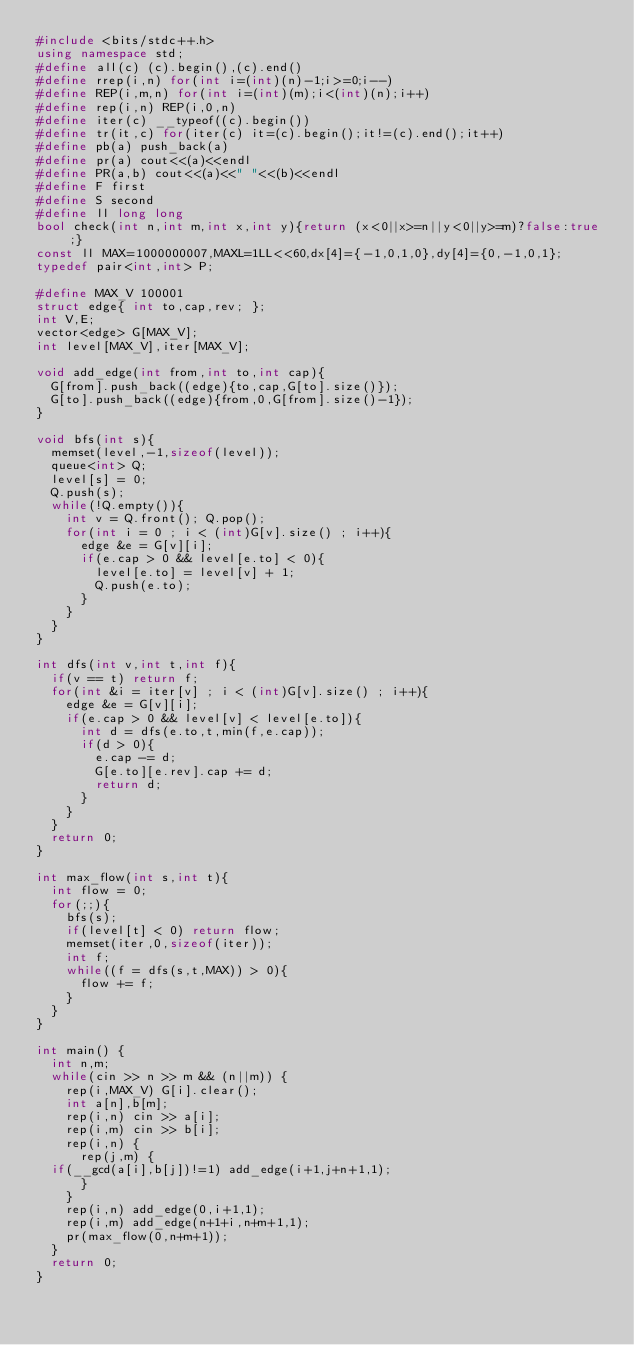<code> <loc_0><loc_0><loc_500><loc_500><_C++_>#include <bits/stdc++.h>
using namespace std;
#define all(c) (c).begin(),(c).end()
#define rrep(i,n) for(int i=(int)(n)-1;i>=0;i--)
#define REP(i,m,n) for(int i=(int)(m);i<(int)(n);i++)
#define rep(i,n) REP(i,0,n)
#define iter(c) __typeof((c).begin())
#define tr(it,c) for(iter(c) it=(c).begin();it!=(c).end();it++)
#define pb(a) push_back(a)
#define pr(a) cout<<(a)<<endl
#define PR(a,b) cout<<(a)<<" "<<(b)<<endl
#define F first
#define S second
#define ll long long
bool check(int n,int m,int x,int y){return (x<0||x>=n||y<0||y>=m)?false:true;}
const ll MAX=1000000007,MAXL=1LL<<60,dx[4]={-1,0,1,0},dy[4]={0,-1,0,1};
typedef pair<int,int> P;

#define MAX_V 100001
struct edge{ int to,cap,rev; };  
int V,E;
vector<edge> G[MAX_V];
int level[MAX_V],iter[MAX_V];
  
void add_edge(int from,int to,int cap){
  G[from].push_back((edge){to,cap,G[to].size()});
  G[to].push_back((edge){from,0,G[from].size()-1});
}
  
void bfs(int s){
  memset(level,-1,sizeof(level));
  queue<int> Q;
  level[s] = 0;
  Q.push(s);
  while(!Q.empty()){
    int v = Q.front(); Q.pop();
    for(int i = 0 ; i < (int)G[v].size() ; i++){
      edge &e = G[v][i];
      if(e.cap > 0 && level[e.to] < 0){
        level[e.to] = level[v] + 1;
        Q.push(e.to);
      }
    }
  }
}
  
int dfs(int v,int t,int f){
  if(v == t) return f;
  for(int &i = iter[v] ; i < (int)G[v].size() ; i++){
    edge &e = G[v][i];
    if(e.cap > 0 && level[v] < level[e.to]){
      int d = dfs(e.to,t,min(f,e.cap));
      if(d > 0){
        e.cap -= d;
        G[e.to][e.rev].cap += d;
        return d;
      }
    }
  }
  return 0;
}
 
int max_flow(int s,int t){
  int flow = 0;
  for(;;){
    bfs(s);
    if(level[t] < 0) return flow;
    memset(iter,0,sizeof(iter));
    int f;
    while((f = dfs(s,t,MAX)) > 0){
      flow += f;
    }
  }
}

int main() {
  int n,m;
  while(cin >> n >> m && (n||m)) {
    rep(i,MAX_V) G[i].clear();
    int a[n],b[m];
    rep(i,n) cin >> a[i];
    rep(i,m) cin >> b[i];
    rep(i,n) {
      rep(j,m) {
	if(__gcd(a[i],b[j])!=1) add_edge(i+1,j+n+1,1);
      }
    }
    rep(i,n) add_edge(0,i+1,1);
    rep(i,m) add_edge(n+1+i,n+m+1,1);
    pr(max_flow(0,n+m+1));
  }
  return 0;
}
</code> 